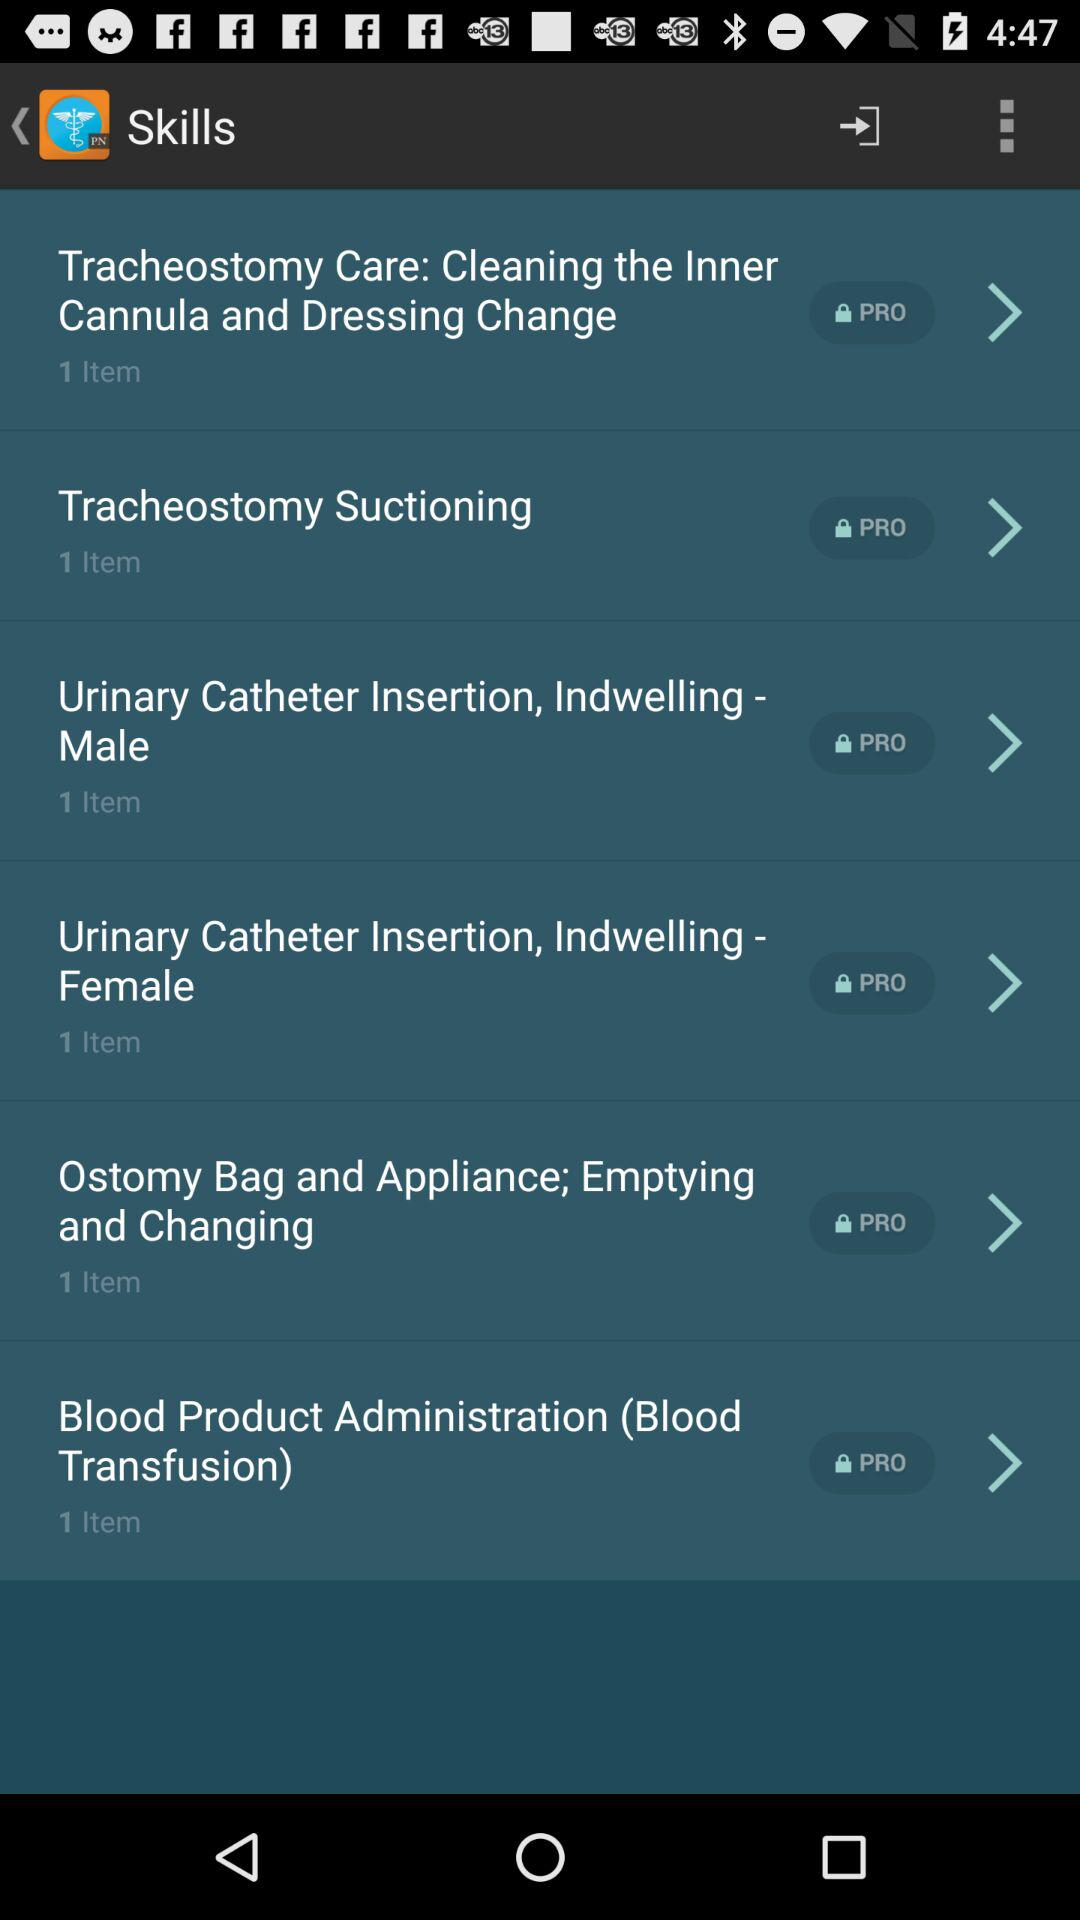How many items are in "Blood Product Administration"? There is 1 item in "Blood Product Administration". 